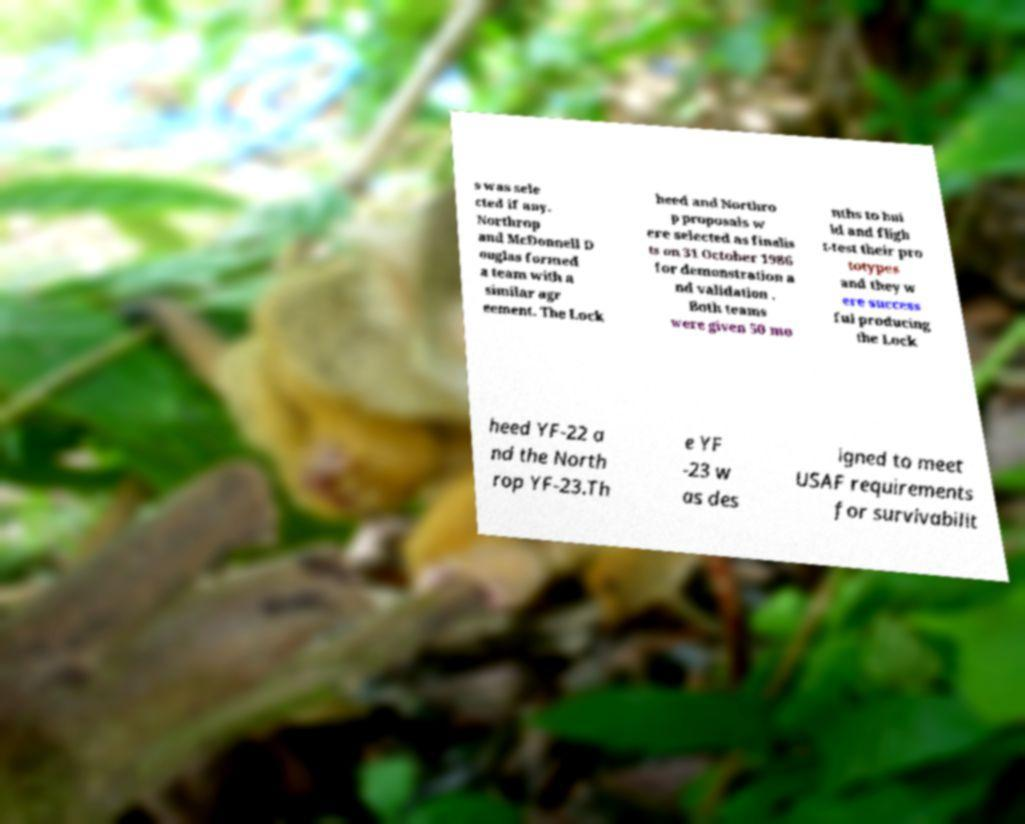Can you read and provide the text displayed in the image?This photo seems to have some interesting text. Can you extract and type it out for me? s was sele cted if any. Northrop and McDonnell D ouglas formed a team with a similar agr eement. The Lock heed and Northro p proposals w ere selected as finalis ts on 31 October 1986 for demonstration a nd validation . Both teams were given 50 mo nths to bui ld and fligh t-test their pro totypes and they w ere success ful producing the Lock heed YF-22 a nd the North rop YF-23.Th e YF -23 w as des igned to meet USAF requirements for survivabilit 